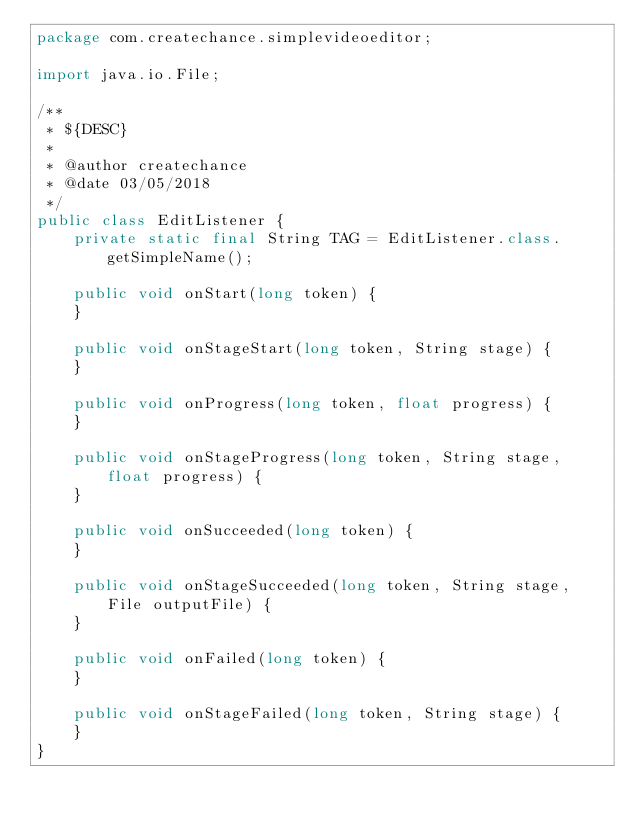Convert code to text. <code><loc_0><loc_0><loc_500><loc_500><_Java_>package com.createchance.simplevideoeditor;

import java.io.File;

/**
 * ${DESC}
 *
 * @author createchance
 * @date 03/05/2018
 */
public class EditListener {
    private static final String TAG = EditListener.class.getSimpleName();

    public void onStart(long token) {
    }

    public void onStageStart(long token, String stage) {
    }

    public void onProgress(long token, float progress) {
    }

    public void onStageProgress(long token, String stage, float progress) {
    }

    public void onSucceeded(long token) {
    }

    public void onStageSucceeded(long token, String stage, File outputFile) {
    }

    public void onFailed(long token) {
    }

    public void onStageFailed(long token, String stage) {
    }
}
</code> 